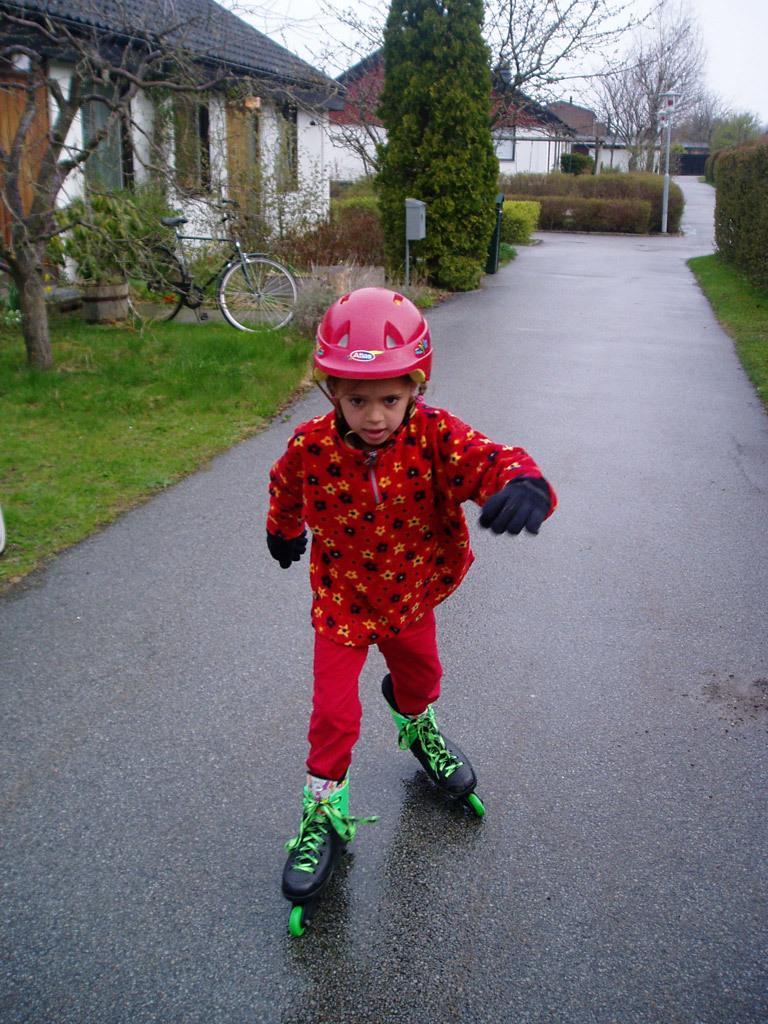How would you summarize this image in a sentence or two? In this image I can see a kid doing skating on the road, beside the road there is a building, trees, bicycle and grass. 